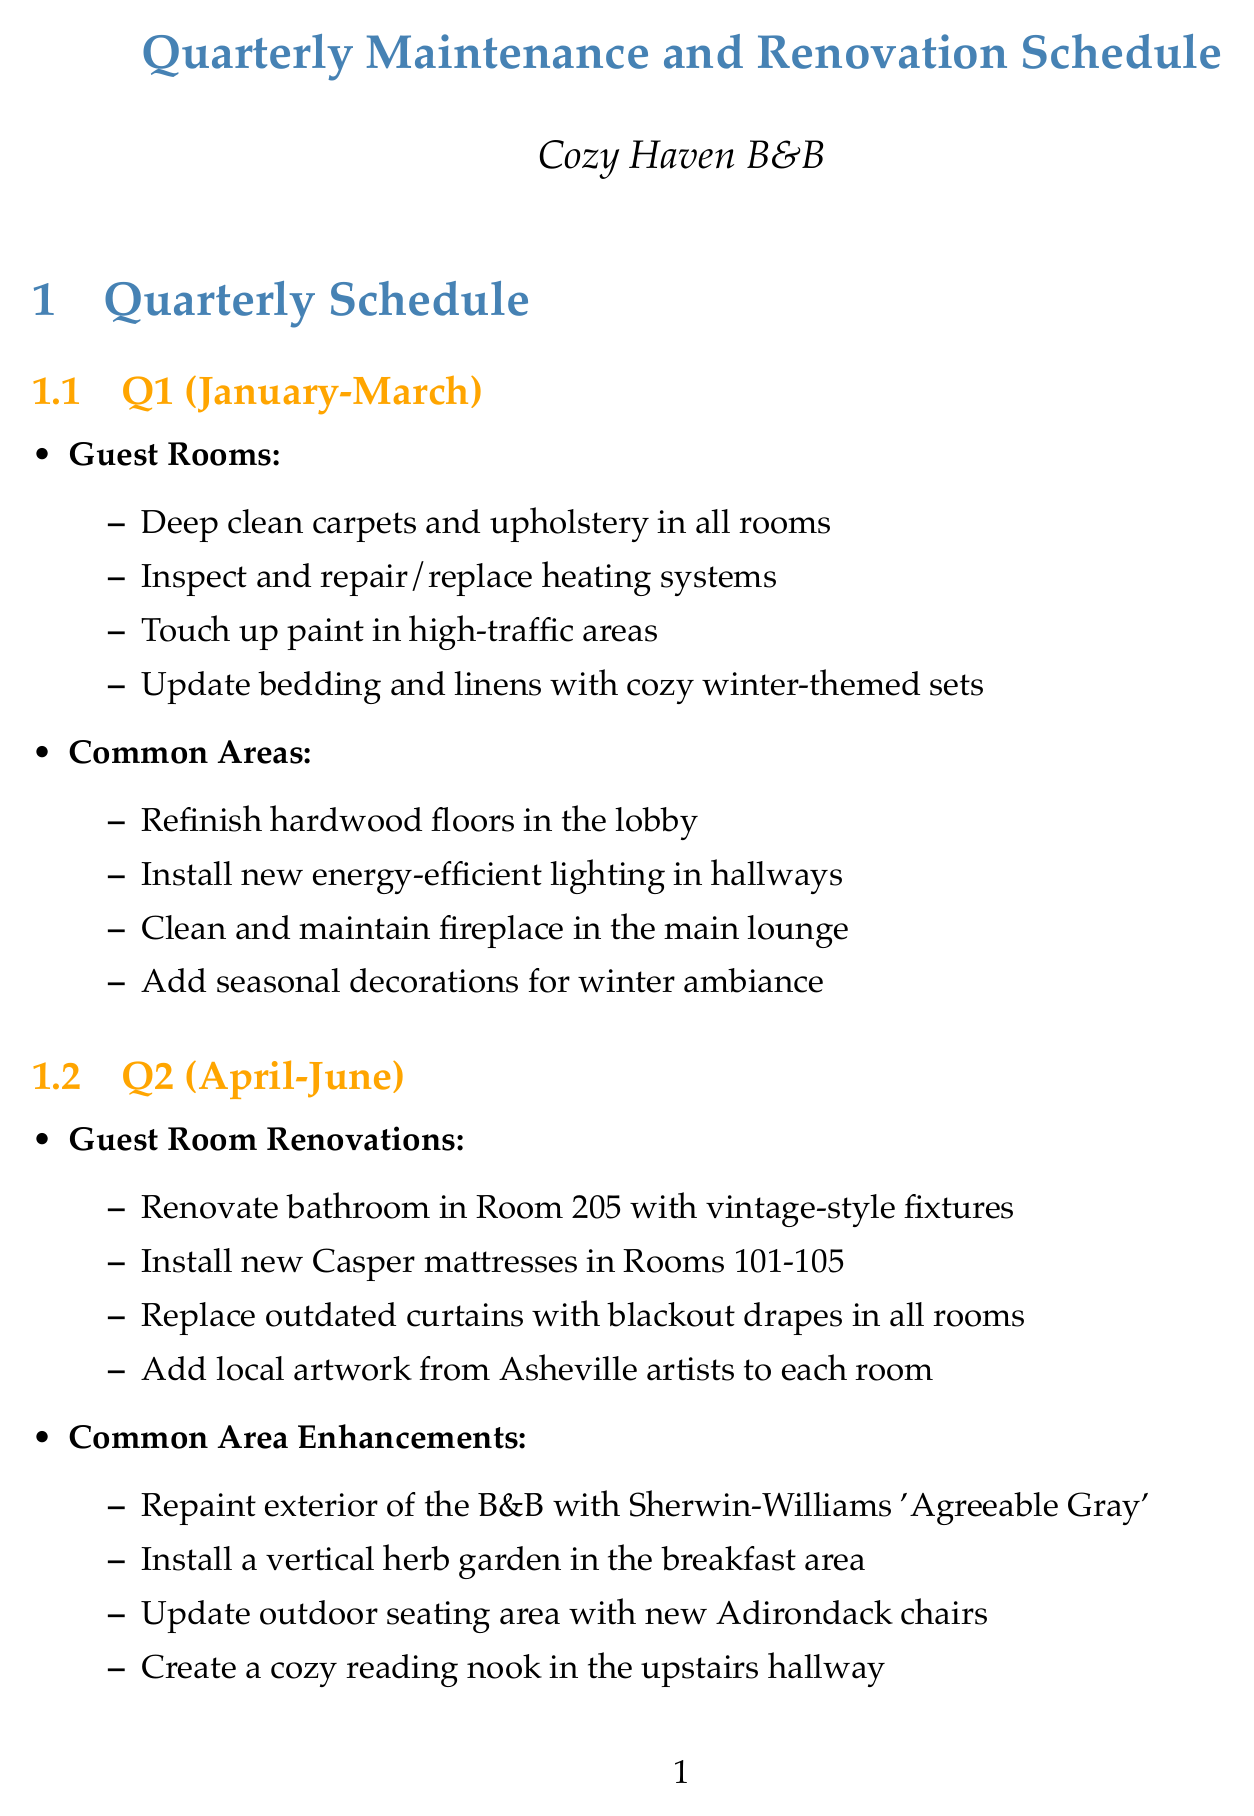What activities are scheduled for Q1? Q1 includes deep cleaning carpets, inspecting heating systems, touching up paint, and updating bedding and linens.
Answer: Deep clean carpets and upholstery, Inspect and repair/replace heating systems, Touch up paint, Update bedding and linens What renovations will occur in Room 205? Room 205 will undergo renovations with vintage-style fixtures in the bathroom.
Answer: Renovate bathroom with vintage-style fixtures How many guest rooms will receive new mattresses in Q2? Five guest rooms (Rooms 101-105) will receive new Casper mattresses as part of the Q2 renovations.
Answer: Five rooms What improvement involves the reception area in Q4? The reception area will be renovated with a rustic check-in counter as part of the Q4 improvements.
Answer: Renovate with a rustic check-in counter What is the first task listed for Q3 guest rooms? The first task listed for Q3 guest rooms is servicing and cleaning air conditioning units.
Answer: Service and clean all air conditioning units How often is pest control scheduled? Pest control treatments are scheduled quarterly, ensuring a pest-free environment for guests.
Answer: Quarterly What is a key feature of the ongoing maintenance? Ongoing maintenance includes weekly deep cleaning of all rooms and common areas to maintain cleanliness.
Answer: Weekly deep cleaning What type of service will be introduced for personalized recommendations? A digital concierge service will be implemented for personalized recommendations to enhance guest experience.
Answer: Digital concierge service 